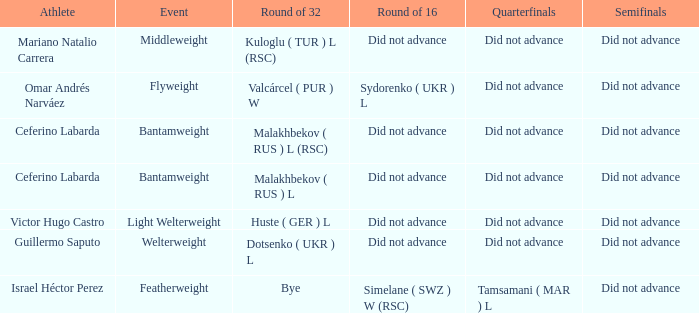Would you be able to parse every entry in this table? {'header': ['Athlete', 'Event', 'Round of 32', 'Round of 16', 'Quarterfinals', 'Semifinals'], 'rows': [['Mariano Natalio Carrera', 'Middleweight', 'Kuloglu ( TUR ) L (RSC)', 'Did not advance', 'Did not advance', 'Did not advance'], ['Omar Andrés Narváez', 'Flyweight', 'Valcárcel ( PUR ) W', 'Sydorenko ( UKR ) L', 'Did not advance', 'Did not advance'], ['Ceferino Labarda', 'Bantamweight', 'Malakhbekov ( RUS ) L (RSC)', 'Did not advance', 'Did not advance', 'Did not advance'], ['Ceferino Labarda', 'Bantamweight', 'Malakhbekov ( RUS ) L', 'Did not advance', 'Did not advance', 'Did not advance'], ['Victor Hugo Castro', 'Light Welterweight', 'Huste ( GER ) L', 'Did not advance', 'Did not advance', 'Did not advance'], ['Guillermo Saputo', 'Welterweight', 'Dotsenko ( UKR ) L', 'Did not advance', 'Did not advance', 'Did not advance'], ['Israel Héctor Perez', 'Featherweight', 'Bye', 'Simelane ( SWZ ) W (RSC)', 'Tamsamani ( MAR ) L', 'Did not advance']]} When there was a bye in the round of 32, what was the result in the round of 16? Did not advance. 